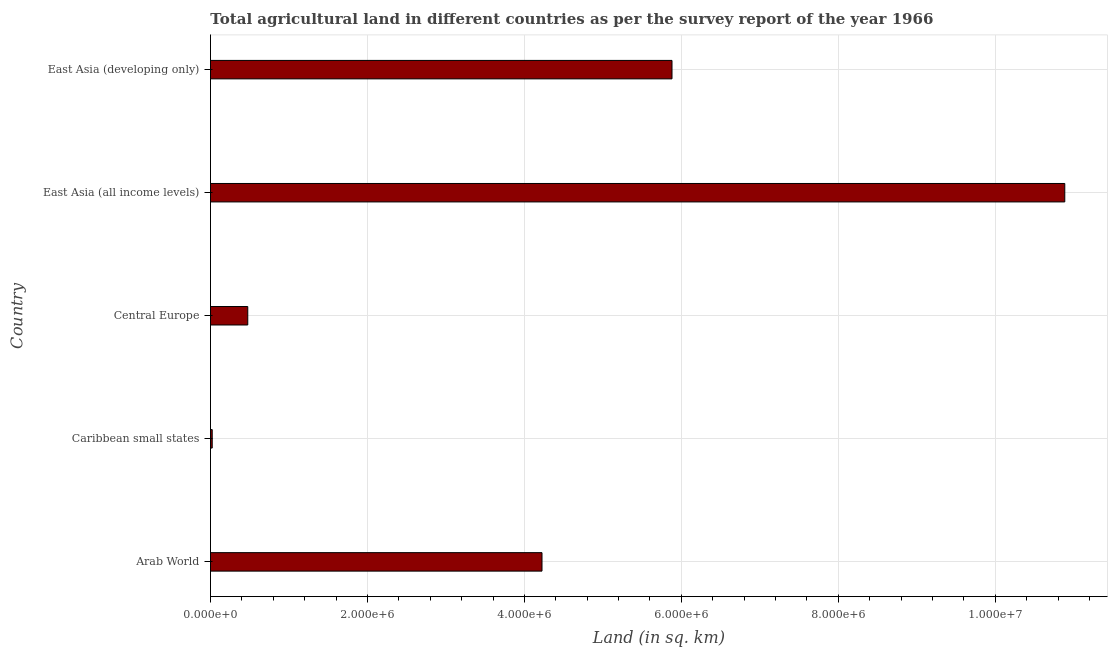What is the title of the graph?
Your answer should be very brief. Total agricultural land in different countries as per the survey report of the year 1966. What is the label or title of the X-axis?
Your answer should be very brief. Land (in sq. km). What is the agricultural land in East Asia (all income levels)?
Ensure brevity in your answer.  1.09e+07. Across all countries, what is the maximum agricultural land?
Your response must be concise. 1.09e+07. Across all countries, what is the minimum agricultural land?
Make the answer very short. 2.23e+04. In which country was the agricultural land maximum?
Your response must be concise. East Asia (all income levels). In which country was the agricultural land minimum?
Offer a very short reply. Caribbean small states. What is the sum of the agricultural land?
Give a very brief answer. 2.15e+07. What is the difference between the agricultural land in Central Europe and East Asia (developing only)?
Make the answer very short. -5.41e+06. What is the average agricultural land per country?
Give a very brief answer. 4.30e+06. What is the median agricultural land?
Offer a terse response. 4.22e+06. In how many countries, is the agricultural land greater than 10800000 sq. km?
Provide a succinct answer. 1. What is the ratio of the agricultural land in Caribbean small states to that in East Asia (developing only)?
Your response must be concise. 0. Is the agricultural land in East Asia (all income levels) less than that in East Asia (developing only)?
Keep it short and to the point. No. Is the difference between the agricultural land in Arab World and East Asia (all income levels) greater than the difference between any two countries?
Offer a terse response. No. What is the difference between the highest and the second highest agricultural land?
Give a very brief answer. 5.00e+06. Is the sum of the agricultural land in Caribbean small states and Central Europe greater than the maximum agricultural land across all countries?
Make the answer very short. No. What is the difference between the highest and the lowest agricultural land?
Keep it short and to the point. 1.09e+07. In how many countries, is the agricultural land greater than the average agricultural land taken over all countries?
Your response must be concise. 2. What is the difference between two consecutive major ticks on the X-axis?
Your response must be concise. 2.00e+06. Are the values on the major ticks of X-axis written in scientific E-notation?
Provide a short and direct response. Yes. What is the Land (in sq. km) in Arab World?
Your answer should be compact. 4.22e+06. What is the Land (in sq. km) of Caribbean small states?
Offer a very short reply. 2.23e+04. What is the Land (in sq. km) in Central Europe?
Keep it short and to the point. 4.75e+05. What is the Land (in sq. km) in East Asia (all income levels)?
Make the answer very short. 1.09e+07. What is the Land (in sq. km) of East Asia (developing only)?
Offer a terse response. 5.88e+06. What is the difference between the Land (in sq. km) in Arab World and Caribbean small states?
Provide a short and direct response. 4.20e+06. What is the difference between the Land (in sq. km) in Arab World and Central Europe?
Keep it short and to the point. 3.75e+06. What is the difference between the Land (in sq. km) in Arab World and East Asia (all income levels)?
Your answer should be compact. -6.66e+06. What is the difference between the Land (in sq. km) in Arab World and East Asia (developing only)?
Offer a terse response. -1.66e+06. What is the difference between the Land (in sq. km) in Caribbean small states and Central Europe?
Your answer should be very brief. -4.53e+05. What is the difference between the Land (in sq. km) in Caribbean small states and East Asia (all income levels)?
Provide a short and direct response. -1.09e+07. What is the difference between the Land (in sq. km) in Caribbean small states and East Asia (developing only)?
Your answer should be compact. -5.86e+06. What is the difference between the Land (in sq. km) in Central Europe and East Asia (all income levels)?
Your response must be concise. -1.04e+07. What is the difference between the Land (in sq. km) in Central Europe and East Asia (developing only)?
Your answer should be very brief. -5.41e+06. What is the difference between the Land (in sq. km) in East Asia (all income levels) and East Asia (developing only)?
Your answer should be very brief. 5.00e+06. What is the ratio of the Land (in sq. km) in Arab World to that in Caribbean small states?
Offer a very short reply. 189.09. What is the ratio of the Land (in sq. km) in Arab World to that in Central Europe?
Offer a terse response. 8.89. What is the ratio of the Land (in sq. km) in Arab World to that in East Asia (all income levels)?
Provide a succinct answer. 0.39. What is the ratio of the Land (in sq. km) in Arab World to that in East Asia (developing only)?
Offer a terse response. 0.72. What is the ratio of the Land (in sq. km) in Caribbean small states to that in Central Europe?
Your response must be concise. 0.05. What is the ratio of the Land (in sq. km) in Caribbean small states to that in East Asia (all income levels)?
Keep it short and to the point. 0. What is the ratio of the Land (in sq. km) in Caribbean small states to that in East Asia (developing only)?
Provide a succinct answer. 0. What is the ratio of the Land (in sq. km) in Central Europe to that in East Asia (all income levels)?
Give a very brief answer. 0.04. What is the ratio of the Land (in sq. km) in Central Europe to that in East Asia (developing only)?
Keep it short and to the point. 0.08. What is the ratio of the Land (in sq. km) in East Asia (all income levels) to that in East Asia (developing only)?
Keep it short and to the point. 1.85. 